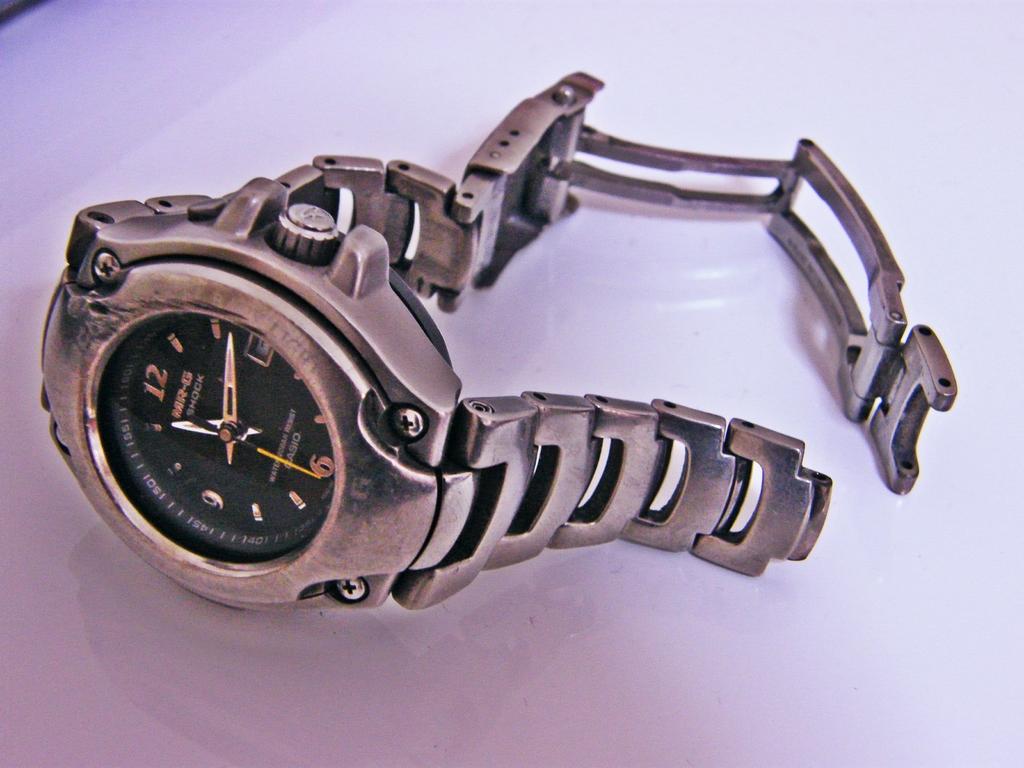What brand is this watch?
Ensure brevity in your answer.  Casio. What time does the watch say?
Offer a very short reply. 11:12. 